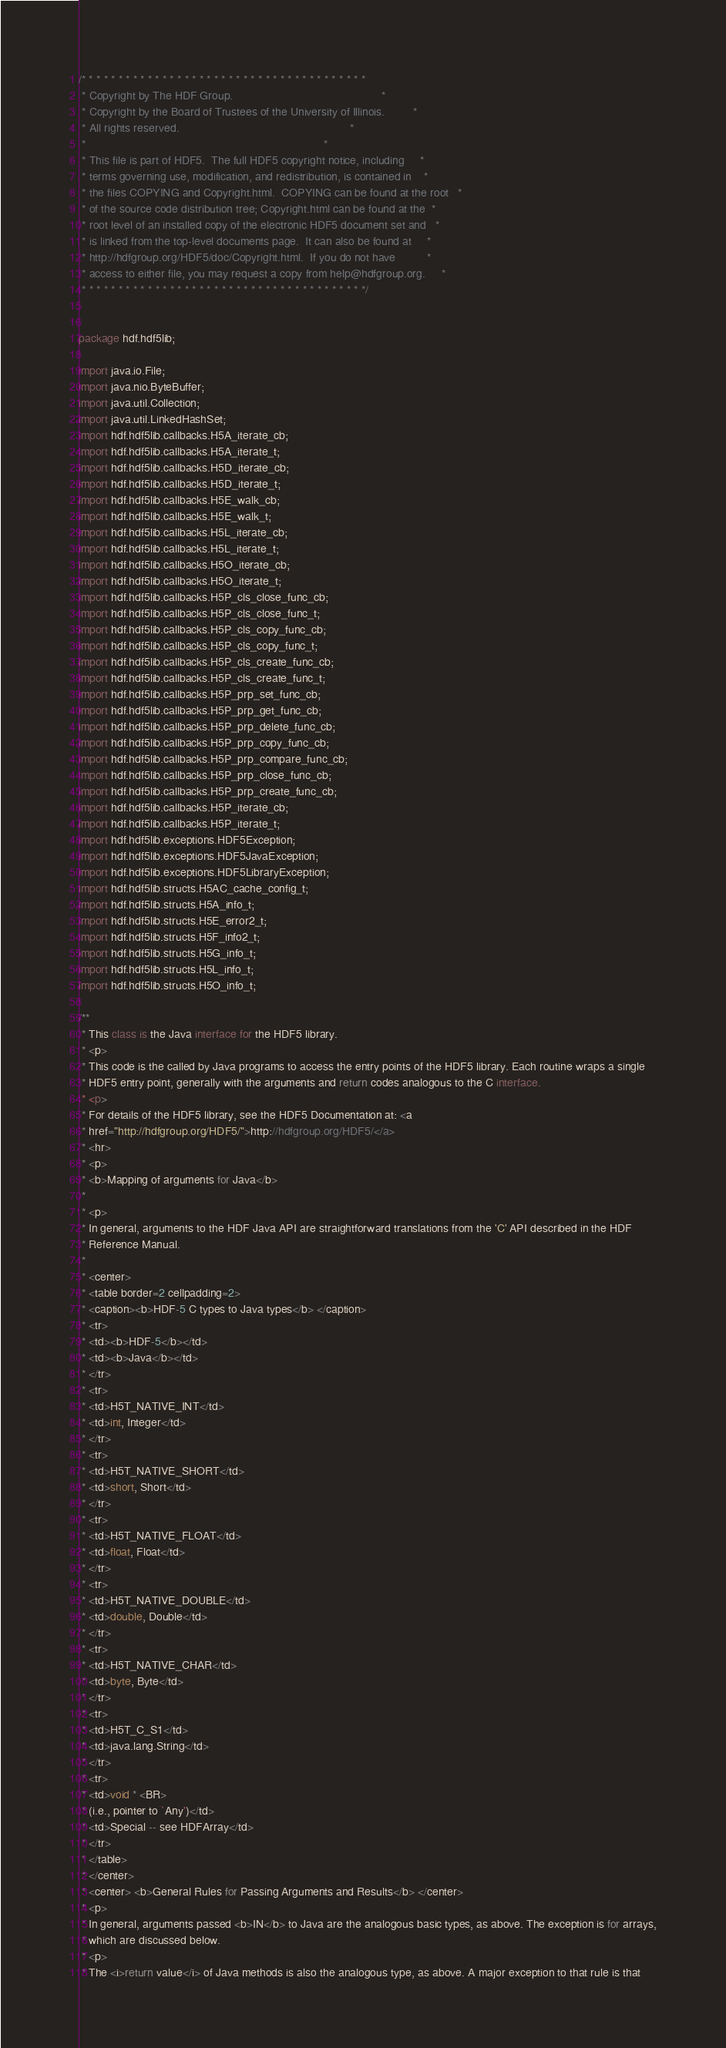<code> <loc_0><loc_0><loc_500><loc_500><_Java_>/* * * * * * * * * * * * * * * * * * * * * * * * * * * * * * * * * * * * * * *
 * Copyright by The HDF Group.                                               *
 * Copyright by the Board of Trustees of the University of Illinois.         *
 * All rights reserved.                                                      *
 *                                                                           *
 * This file is part of HDF5.  The full HDF5 copyright notice, including     *
 * terms governing use, modification, and redistribution, is contained in    *
 * the files COPYING and Copyright.html.  COPYING can be found at the root   *
 * of the source code distribution tree; Copyright.html can be found at the  *
 * root level of an installed copy of the electronic HDF5 document set and   *
 * is linked from the top-level documents page.  It can also be found at     *
 * http://hdfgroup.org/HDF5/doc/Copyright.html.  If you do not have          *
 * access to either file, you may request a copy from help@hdfgroup.org.     *
 * * * * * * * * * * * * * * * * * * * * * * * * * * * * * * * * * * * * * * */


package hdf.hdf5lib;

import java.io.File;
import java.nio.ByteBuffer;
import java.util.Collection;
import java.util.LinkedHashSet;
import hdf.hdf5lib.callbacks.H5A_iterate_cb;
import hdf.hdf5lib.callbacks.H5A_iterate_t;
import hdf.hdf5lib.callbacks.H5D_iterate_cb;
import hdf.hdf5lib.callbacks.H5D_iterate_t;
import hdf.hdf5lib.callbacks.H5E_walk_cb;
import hdf.hdf5lib.callbacks.H5E_walk_t;
import hdf.hdf5lib.callbacks.H5L_iterate_cb;
import hdf.hdf5lib.callbacks.H5L_iterate_t;
import hdf.hdf5lib.callbacks.H5O_iterate_cb;
import hdf.hdf5lib.callbacks.H5O_iterate_t;
import hdf.hdf5lib.callbacks.H5P_cls_close_func_cb;
import hdf.hdf5lib.callbacks.H5P_cls_close_func_t;
import hdf.hdf5lib.callbacks.H5P_cls_copy_func_cb;
import hdf.hdf5lib.callbacks.H5P_cls_copy_func_t;
import hdf.hdf5lib.callbacks.H5P_cls_create_func_cb;
import hdf.hdf5lib.callbacks.H5P_cls_create_func_t;
import hdf.hdf5lib.callbacks.H5P_prp_set_func_cb;
import hdf.hdf5lib.callbacks.H5P_prp_get_func_cb;
import hdf.hdf5lib.callbacks.H5P_prp_delete_func_cb;
import hdf.hdf5lib.callbacks.H5P_prp_copy_func_cb;
import hdf.hdf5lib.callbacks.H5P_prp_compare_func_cb;
import hdf.hdf5lib.callbacks.H5P_prp_close_func_cb;
import hdf.hdf5lib.callbacks.H5P_prp_create_func_cb;
import hdf.hdf5lib.callbacks.H5P_iterate_cb;
import hdf.hdf5lib.callbacks.H5P_iterate_t;
import hdf.hdf5lib.exceptions.HDF5Exception;
import hdf.hdf5lib.exceptions.HDF5JavaException;
import hdf.hdf5lib.exceptions.HDF5LibraryException;
import hdf.hdf5lib.structs.H5AC_cache_config_t;
import hdf.hdf5lib.structs.H5A_info_t;
import hdf.hdf5lib.structs.H5E_error2_t;
import hdf.hdf5lib.structs.H5F_info2_t;
import hdf.hdf5lib.structs.H5G_info_t;
import hdf.hdf5lib.structs.H5L_info_t;
import hdf.hdf5lib.structs.H5O_info_t;

/**
 * This class is the Java interface for the HDF5 library.
 * <p>
 * This code is the called by Java programs to access the entry points of the HDF5 library. Each routine wraps a single
 * HDF5 entry point, generally with the arguments and return codes analogous to the C interface.
 * <p>
 * For details of the HDF5 library, see the HDF5 Documentation at: <a
 * href="http://hdfgroup.org/HDF5/">http://hdfgroup.org/HDF5/</a>
 * <hr>
 * <p>
 * <b>Mapping of arguments for Java</b>
 *
 * <p>
 * In general, arguments to the HDF Java API are straightforward translations from the 'C' API described in the HDF
 * Reference Manual.
 *
 * <center>
 * <table border=2 cellpadding=2>
 * <caption><b>HDF-5 C types to Java types</b> </caption>
 * <tr>
 * <td><b>HDF-5</b></td>
 * <td><b>Java</b></td>
 * </tr>
 * <tr>
 * <td>H5T_NATIVE_INT</td>
 * <td>int, Integer</td>
 * </tr>
 * <tr>
 * <td>H5T_NATIVE_SHORT</td>
 * <td>short, Short</td>
 * </tr>
 * <tr>
 * <td>H5T_NATIVE_FLOAT</td>
 * <td>float, Float</td>
 * </tr>
 * <tr>
 * <td>H5T_NATIVE_DOUBLE</td>
 * <td>double, Double</td>
 * </tr>
 * <tr>
 * <td>H5T_NATIVE_CHAR</td>
 * <td>byte, Byte</td>
 * </tr>
 * <tr>
 * <td>H5T_C_S1</td>
 * <td>java.lang.String</td>
 * </tr>
 * <tr>
 * <td>void * <BR>
 * (i.e., pointer to `Any')</td>
 * <td>Special -- see HDFArray</td>
 * </tr>
 * </table>
 * </center>
 * <center> <b>General Rules for Passing Arguments and Results</b> </center>
 * <p>
 * In general, arguments passed <b>IN</b> to Java are the analogous basic types, as above. The exception is for arrays,
 * which are discussed below.
 * <p>
 * The <i>return value</i> of Java methods is also the analogous type, as above. A major exception to that rule is that</code> 